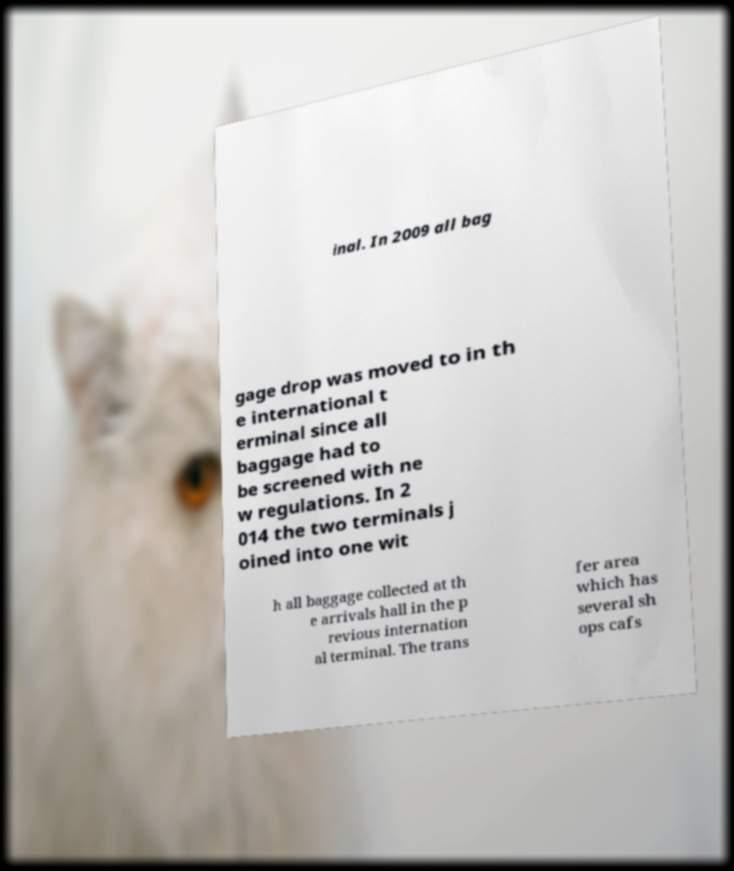There's text embedded in this image that I need extracted. Can you transcribe it verbatim? inal. In 2009 all bag gage drop was moved to in th e international t erminal since all baggage had to be screened with ne w regulations. In 2 014 the two terminals j oined into one wit h all baggage collected at th e arrivals hall in the p revious internation al terminal. The trans fer area which has several sh ops cafs 